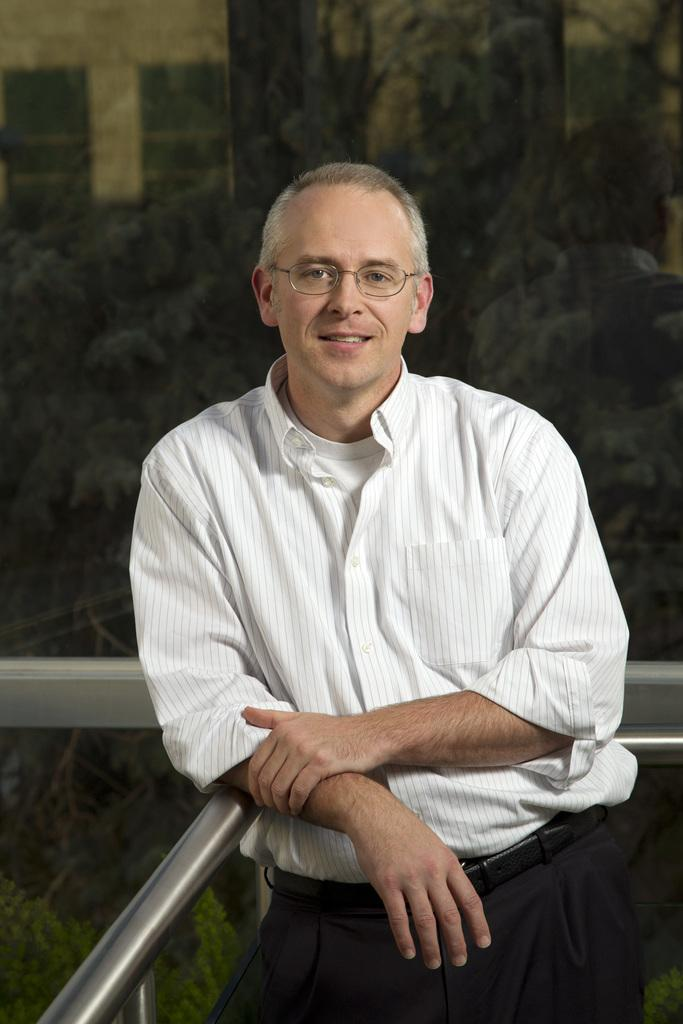What is the main subject of the image? There is a person standing in the center of the image. What can be seen in the background of the image? There are trees and a building in the background of the image. What type of corn is growing on the dock in the image? There is no dock or corn present in the image. What memory does the person in the image have about the trees in the background? The image does not provide any information about the person's memories or thoughts, so we cannot answer this question. 